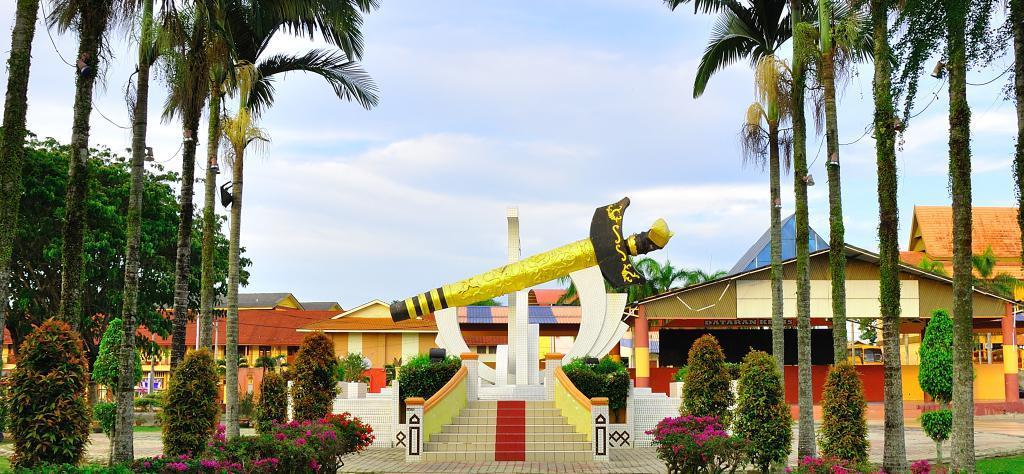Describe this image in one or two sentences. In this picture we can see few flowers, trees and buildings, in the background we can see clouds, in the middle of the image we can see a sculpture. 